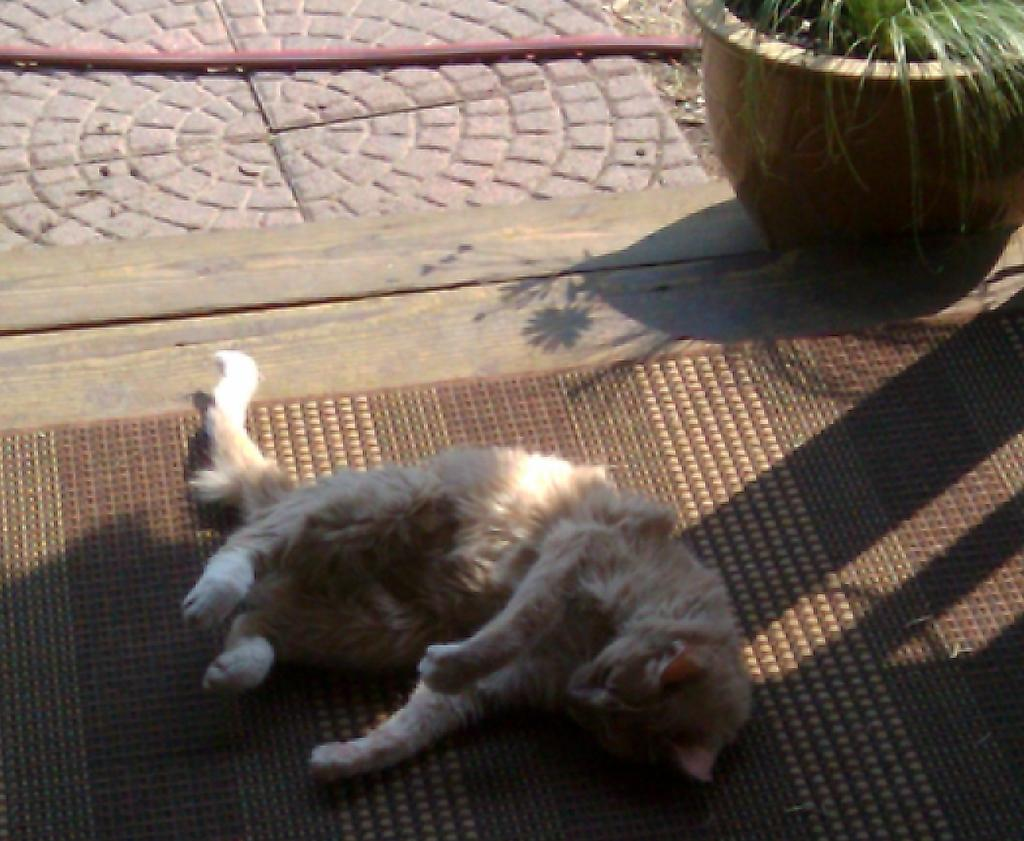What type of animal is in the image? There is a cat in the image. What is the cat doing in the image? The cat is lying on the floor. What else can be seen in the image besides the cat? There is a plant in a pot in the image. What type of noise is the cat making in the image? The image does not provide any information about the cat making a noise. 